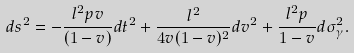<formula> <loc_0><loc_0><loc_500><loc_500>\ d s ^ { 2 } = - \frac { l ^ { 2 } p v } { ( 1 - v ) } d t ^ { 2 } + \frac { l ^ { 2 } } { 4 v ( 1 - v ) ^ { 2 } } d v ^ { 2 } + \frac { l ^ { 2 } p } { 1 - v } d \sigma _ { \gamma } ^ { 2 } .</formula> 